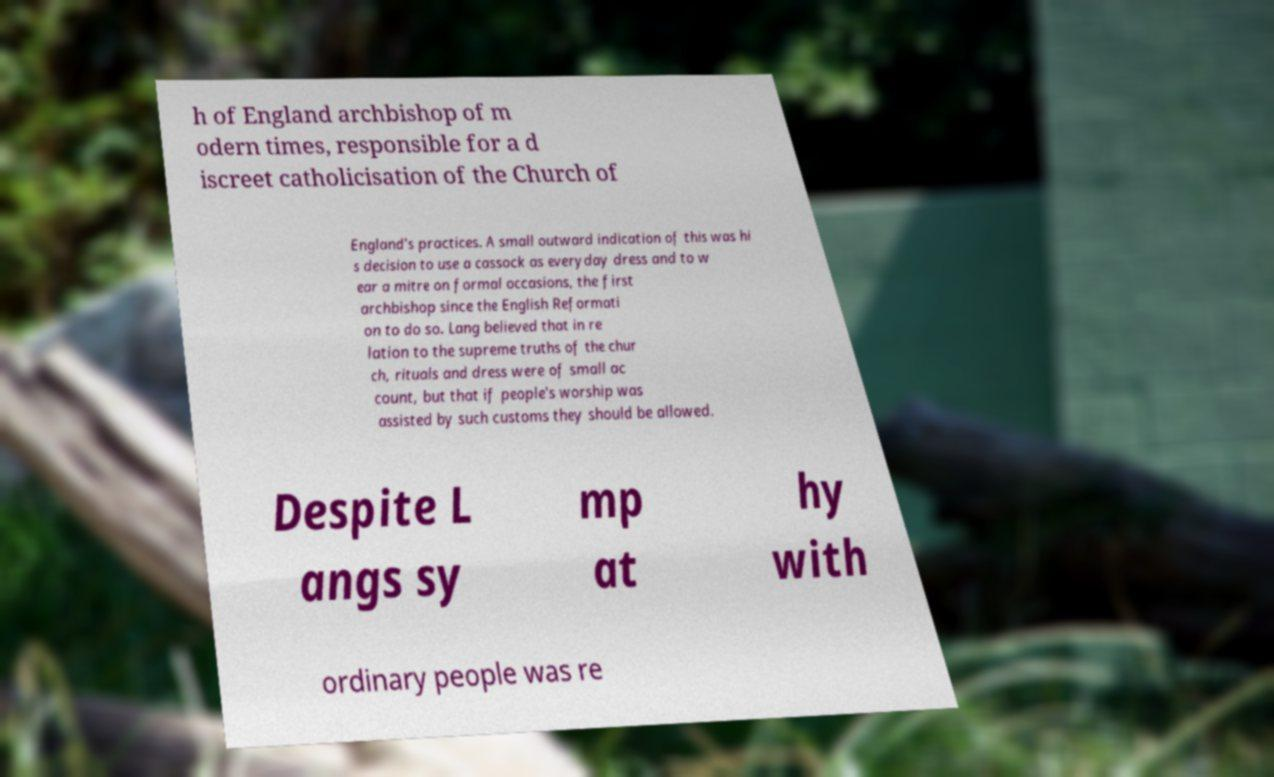Please identify and transcribe the text found in this image. h of England archbishop of m odern times, responsible for a d iscreet catholicisation of the Church of England's practices. A small outward indication of this was hi s decision to use a cassock as everyday dress and to w ear a mitre on formal occasions, the first archbishop since the English Reformati on to do so. Lang believed that in re lation to the supreme truths of the chur ch, rituals and dress were of small ac count, but that if people's worship was assisted by such customs they should be allowed. Despite L angs sy mp at hy with ordinary people was re 